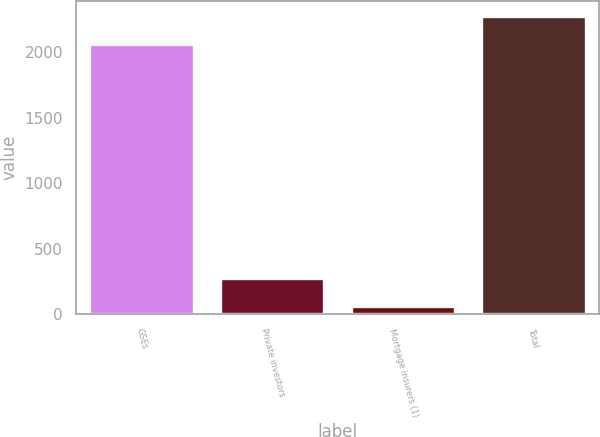<chart> <loc_0><loc_0><loc_500><loc_500><bar_chart><fcel>GSEs<fcel>Private investors<fcel>Mortgage insurers (1)<fcel>Total<nl><fcel>2063<fcel>271.6<fcel>58<fcel>2276.6<nl></chart> 